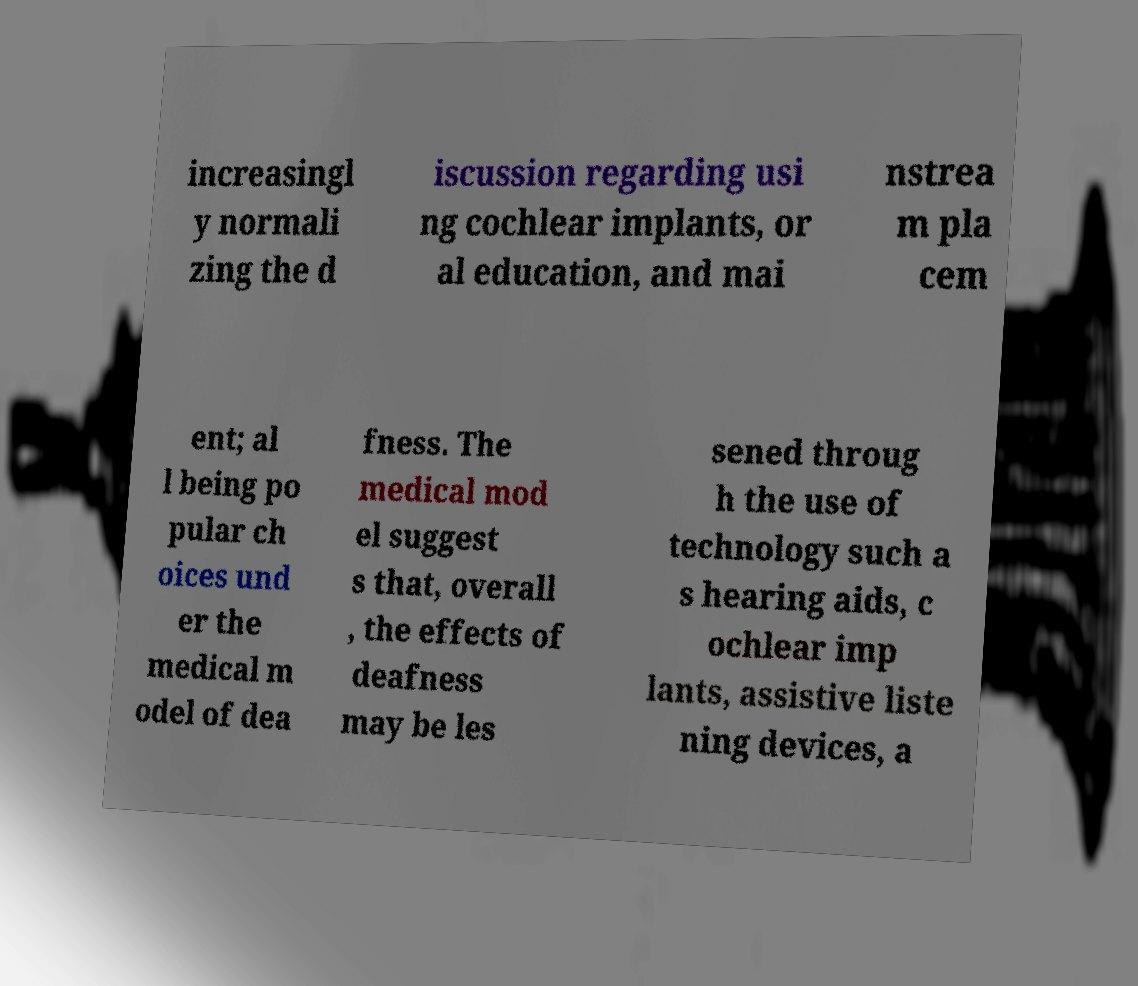Could you assist in decoding the text presented in this image and type it out clearly? increasingl y normali zing the d iscussion regarding usi ng cochlear implants, or al education, and mai nstrea m pla cem ent; al l being po pular ch oices und er the medical m odel of dea fness. The medical mod el suggest s that, overall , the effects of deafness may be les sened throug h the use of technology such a s hearing aids, c ochlear imp lants, assistive liste ning devices, a 